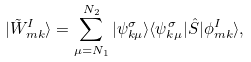<formula> <loc_0><loc_0><loc_500><loc_500>| \tilde { W } ^ { I } _ { m k } \rangle = \sum _ { \mu = N _ { 1 } } ^ { N _ { 2 } } | \psi ^ { \sigma } _ { k \mu } \rangle \langle \psi ^ { \sigma } _ { k \mu } | \hat { S } | \phi ^ { I } _ { m k } \rangle ,</formula> 